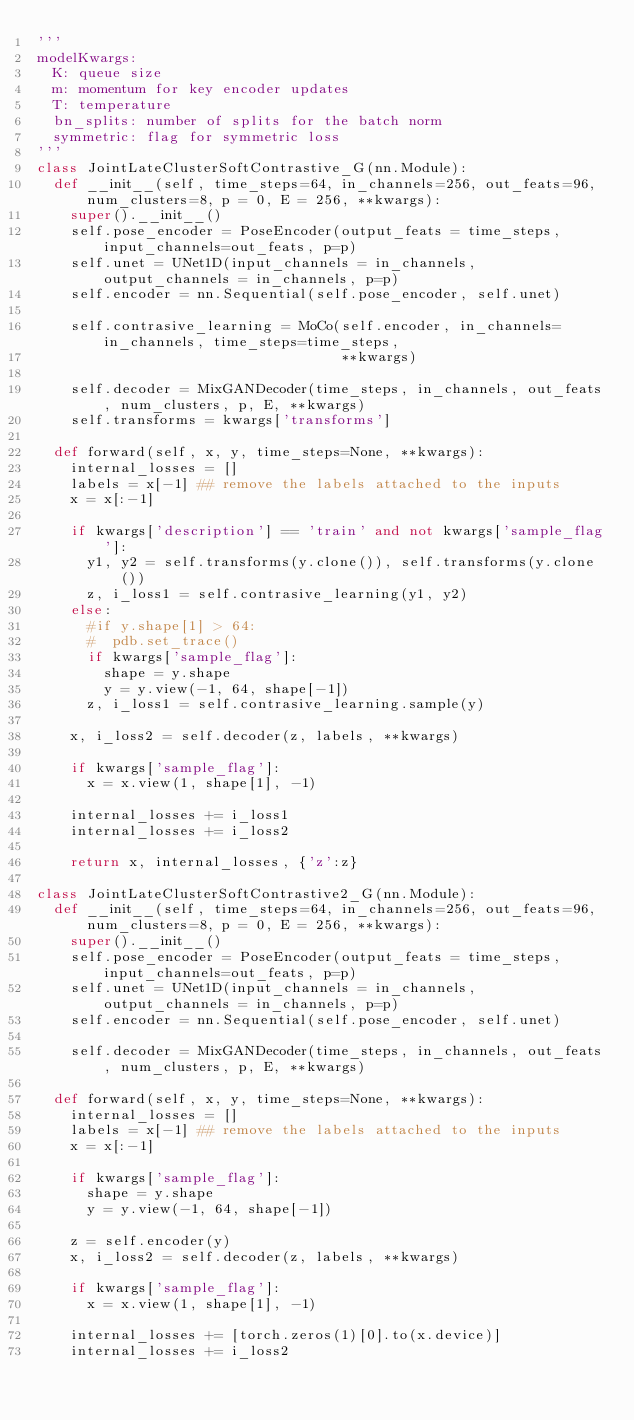Convert code to text. <code><loc_0><loc_0><loc_500><loc_500><_Python_>'''
modelKwargs:
  K: queue size
  m: momentum for key encoder updates
  T: temperature
  bn_splits: number of splits for the batch norm
  symmetric: flag for symmetric loss
'''
class JointLateClusterSoftContrastive_G(nn.Module):
  def __init__(self, time_steps=64, in_channels=256, out_feats=96, num_clusters=8, p = 0, E = 256, **kwargs):
    super().__init__()
    self.pose_encoder = PoseEncoder(output_feats = time_steps, input_channels=out_feats, p=p)
    self.unet = UNet1D(input_channels = in_channels, output_channels = in_channels, p=p)
    self.encoder = nn.Sequential(self.pose_encoder, self.unet)

    self.contrasive_learning = MoCo(self.encoder, in_channels=in_channels, time_steps=time_steps,
                                    **kwargs)

    self.decoder = MixGANDecoder(time_steps, in_channels, out_feats, num_clusters, p, E, **kwargs)
    self.transforms = kwargs['transforms']

  def forward(self, x, y, time_steps=None, **kwargs):
    internal_losses = []
    labels = x[-1] ## remove the labels attached to the inputs
    x = x[:-1]

    if kwargs['description'] == 'train' and not kwargs['sample_flag']:
      y1, y2 = self.transforms(y.clone()), self.transforms(y.clone())
      z, i_loss1 = self.contrasive_learning(y1, y2)
    else:
      #if y.shape[1] > 64:
      #  pdb.set_trace()
      if kwargs['sample_flag']:
        shape = y.shape
        y = y.view(-1, 64, shape[-1])
      z, i_loss1 = self.contrasive_learning.sample(y)

    x, i_loss2 = self.decoder(z, labels, **kwargs)

    if kwargs['sample_flag']:
      x = x.view(1, shape[1], -1)

    internal_losses += i_loss1
    internal_losses += i_loss2

    return x, internal_losses, {'z':z}

class JointLateClusterSoftContrastive2_G(nn.Module):
  def __init__(self, time_steps=64, in_channels=256, out_feats=96, num_clusters=8, p = 0, E = 256, **kwargs):
    super().__init__()
    self.pose_encoder = PoseEncoder(output_feats = time_steps, input_channels=out_feats, p=p)
    self.unet = UNet1D(input_channels = in_channels, output_channels = in_channels, p=p)
    self.encoder = nn.Sequential(self.pose_encoder, self.unet)

    self.decoder = MixGANDecoder(time_steps, in_channels, out_feats, num_clusters, p, E, **kwargs)

  def forward(self, x, y, time_steps=None, **kwargs):
    internal_losses = []
    labels = x[-1] ## remove the labels attached to the inputs
    x = x[:-1]

    if kwargs['sample_flag']:
      shape = y.shape
      y = y.view(-1, 64, shape[-1])

    z = self.encoder(y)
    x, i_loss2 = self.decoder(z, labels, **kwargs)

    if kwargs['sample_flag']:
      x = x.view(1, shape[1], -1)

    internal_losses += [torch.zeros(1)[0].to(x.device)]
    internal_losses += i_loss2
</code> 